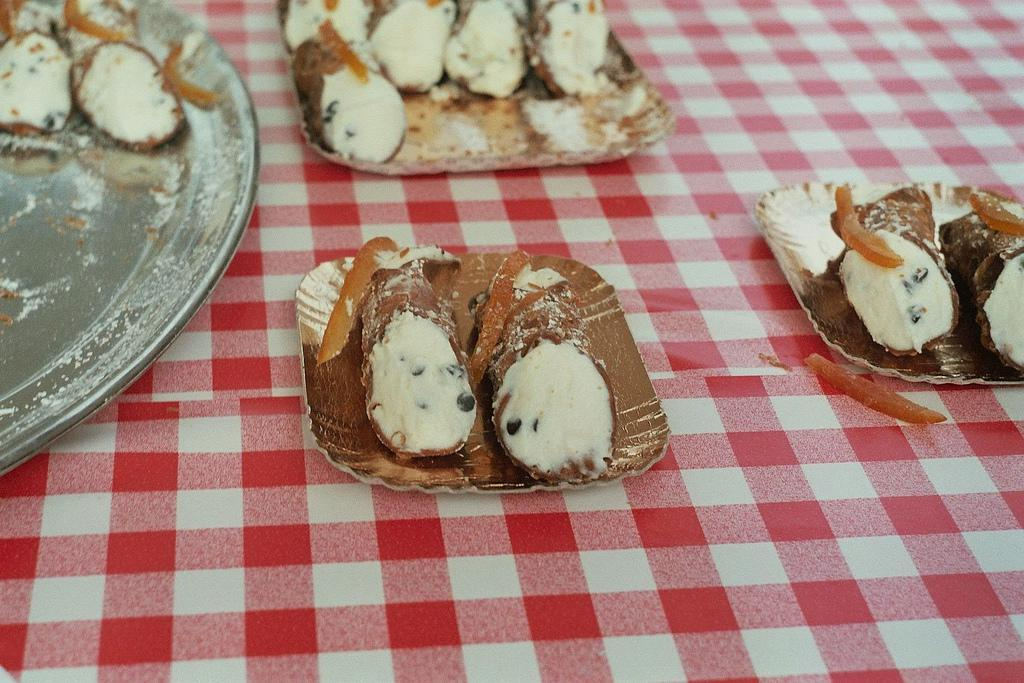What is covering the table in the image? There is a check cloth covering the table in the image. What type of plates are on the table? There are paper plates with food items on the table. Can you describe the food items on the plates? There is a food item on the paper plates, but the specific food item is not mentioned in the facts. Are there any other plates with food items on the table? Yes, there is another plate with a food item on the table. What type of drug is being used to start the picture? There is no drug present in the image, and the concept of "starting" a picture is not applicable in this context. 